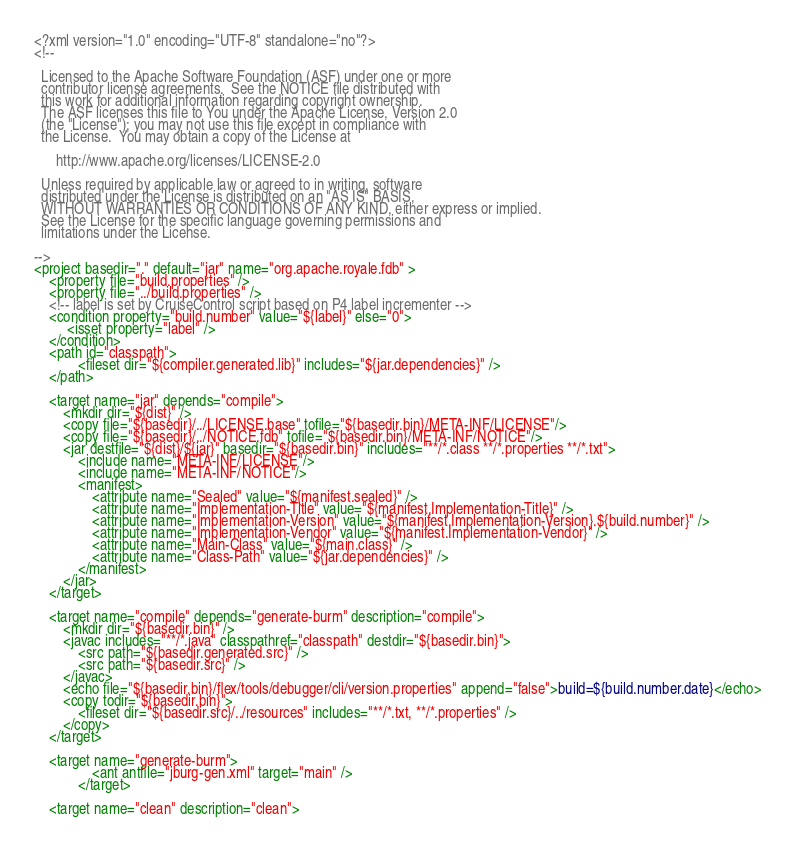Convert code to text. <code><loc_0><loc_0><loc_500><loc_500><_XML_><?xml version="1.0" encoding="UTF-8" standalone="no"?>
<!--

  Licensed to the Apache Software Foundation (ASF) under one or more
  contributor license agreements.  See the NOTICE file distributed with
  this work for additional information regarding copyright ownership.
  The ASF licenses this file to You under the Apache License, Version 2.0
  (the "License"); you may not use this file except in compliance with
  the License.  You may obtain a copy of the License at

      http://www.apache.org/licenses/LICENSE-2.0

  Unless required by applicable law or agreed to in writing, software
  distributed under the License is distributed on an "AS IS" BASIS,
  WITHOUT WARRANTIES OR CONDITIONS OF ANY KIND, either express or implied.
  See the License for the specific language governing permissions and
  limitations under the License.

-->
<project basedir="." default="jar" name="org.apache.royale.fdb" >
	<property file="build.properties" />
    <property file="../build.properties" />
	<!-- label is set by CruiseControl script based on P4 label incrementer -->
	<condition property="build.number" value="${label}" else="0">
	     <isset property="label" />
	</condition>
	<path id="classpath">
			<fileset dir="${compiler.generated.lib}" includes="${jar.dependencies}" />
    </path>

    <target name="jar" depends="compile">
        <mkdir dir="${dist}" />
        <copy file="${basedir}/../LICENSE.base" tofile="${basedir.bin}/META-INF/LICENSE"/>
        <copy file="${basedir}/../NOTICE.fdb" tofile="${basedir.bin}/META-INF/NOTICE"/>
        <jar destfile="${dist}/${jar}" basedir="${basedir.bin}" includes="**/*.class **/*.properties **/*.txt">
            <include name="META-INF/LICENSE"/>
            <include name="META-INF/NOTICE"/>
            <manifest>
                <attribute name="Sealed" value="${manifest.sealed}" />
                <attribute name="Implementation-Title" value="${manifest.Implementation-Title}" />
                <attribute name="Implementation-Version" value="${manifest.Implementation-Version}.${build.number}" />
                <attribute name="Implementation-Vendor" value="${manifest.Implementation-Vendor}" />
                <attribute name="Main-Class" value="${main.class}" />
                <attribute name="Class-Path" value="${jar.dependencies}" />
            </manifest>
        </jar>
    </target>

    <target name="compile" depends="generate-burm" description="compile">
        <mkdir dir="${basedir.bin}" />
        <javac includes="**/*.java" classpathref="classpath" destdir="${basedir.bin}">
            <src path="${basedir.generated.src}" />
            <src path="${basedir.src}" />
        </javac>
        <echo file="${basedir.bin}/flex/tools/debugger/cli/version.properties" append="false">build=${build.number.date}</echo>
        <copy todir="${basedir.bin}">
            <fileset dir="${basedir.src}/../resources" includes="**/*.txt, **/*.properties" />
        </copy>
    </target>
    
    <target name="generate-burm">
                <ant antfile="jburg-gen.xml" target="main" />
            </target>

    <target name="clean" description="clean"></code> 